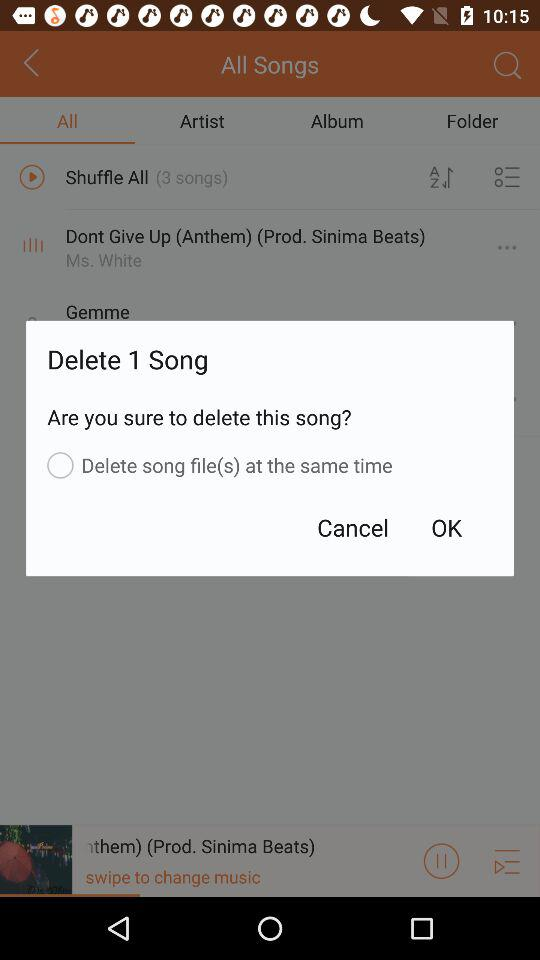How many songs are there to delete? There is 1 song to delete. 